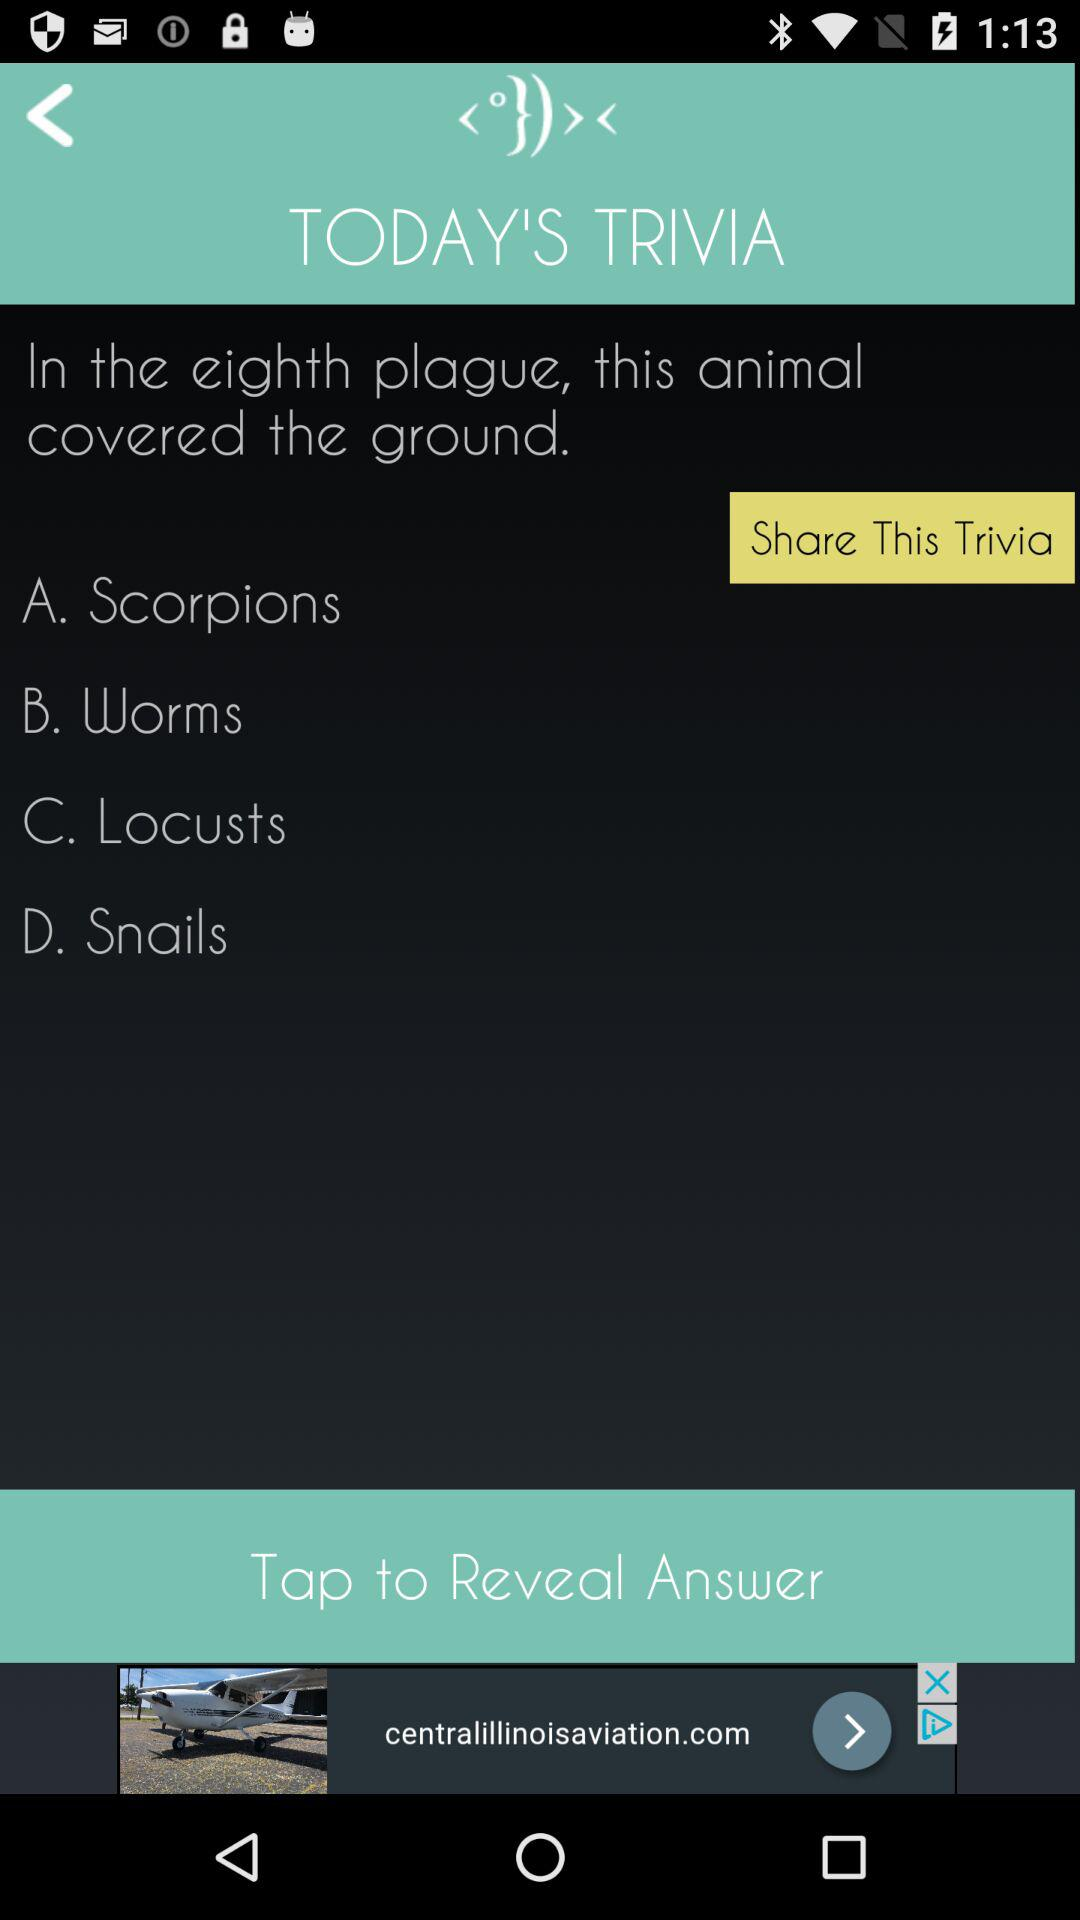How many answer choices are there?
Answer the question using a single word or phrase. 4 